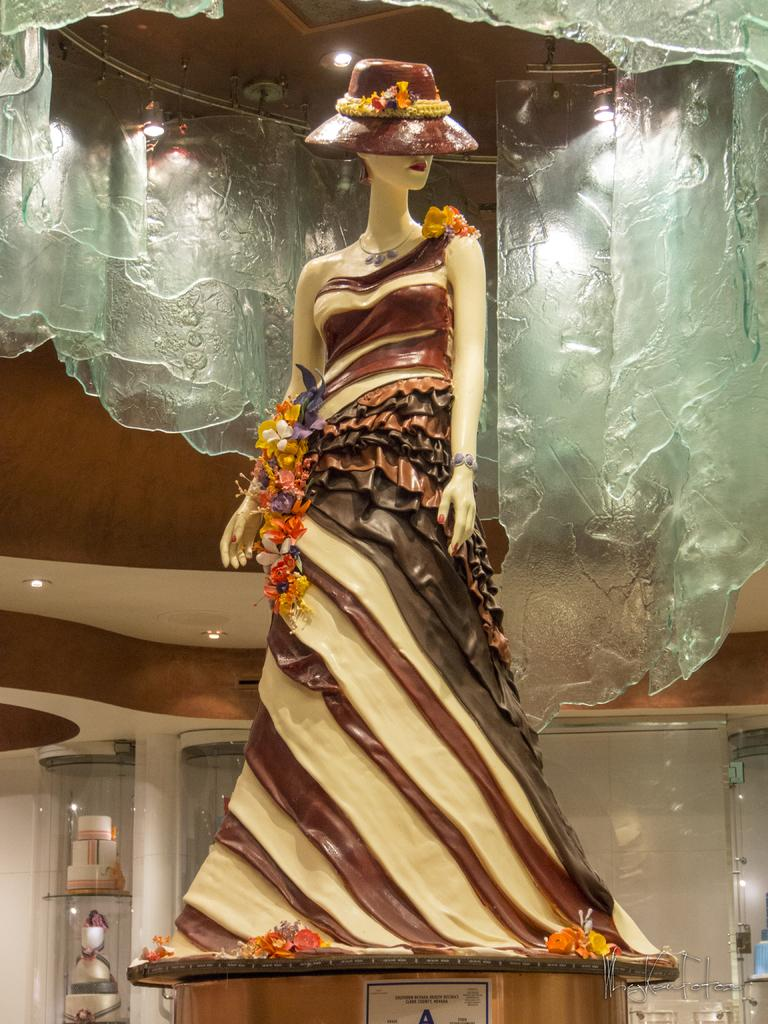What is the main subject of the image? There is a doll in the image. Can you describe the doll's attire? The doll is wearing a dress with different colors. What part of a building can be seen in the image? There is an inner part of a building visible in the image. What type of food is present in the image? There are cakes in the image. What architectural feature is visible in the image? There are pillars in the image. What type of books can be seen on the doll's hands in the image? There are no books present in the image, and the doll's hands are not shown holding any objects. What is the doll using to fix the broken nail in the image? There is no mention of a broken nail or any tools in the image; the doll is simply wearing a dress with different colors. 